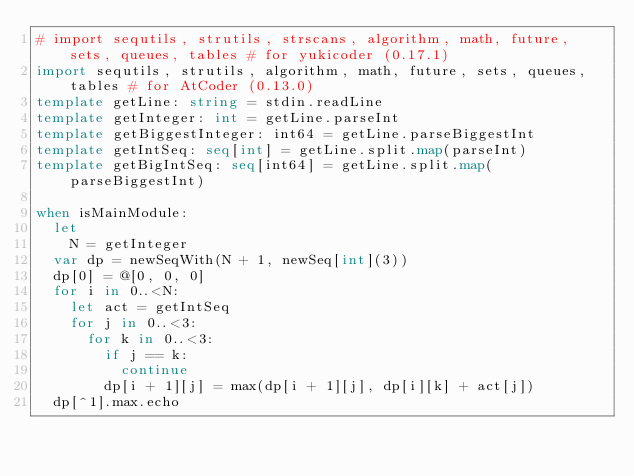<code> <loc_0><loc_0><loc_500><loc_500><_Nim_># import sequtils, strutils, strscans, algorithm, math, future, sets, queues, tables # for yukicoder (0.17.1)
import sequtils, strutils, algorithm, math, future, sets, queues, tables # for AtCoder (0.13.0)
template getLine: string = stdin.readLine
template getInteger: int = getLine.parseInt
template getBiggestInteger: int64 = getLine.parseBiggestInt
template getIntSeq: seq[int] = getLine.split.map(parseInt)
template getBigIntSeq: seq[int64] = getLine.split.map(parseBiggestInt)

when isMainModule:
  let
    N = getInteger
  var dp = newSeqWith(N + 1, newSeq[int](3))
  dp[0] = @[0, 0, 0]
  for i in 0..<N:
    let act = getIntSeq
    for j in 0..<3:
      for k in 0..<3:
        if j == k:
          continue
        dp[i + 1][j] = max(dp[i + 1][j], dp[i][k] + act[j])
  dp[^1].max.echo
</code> 